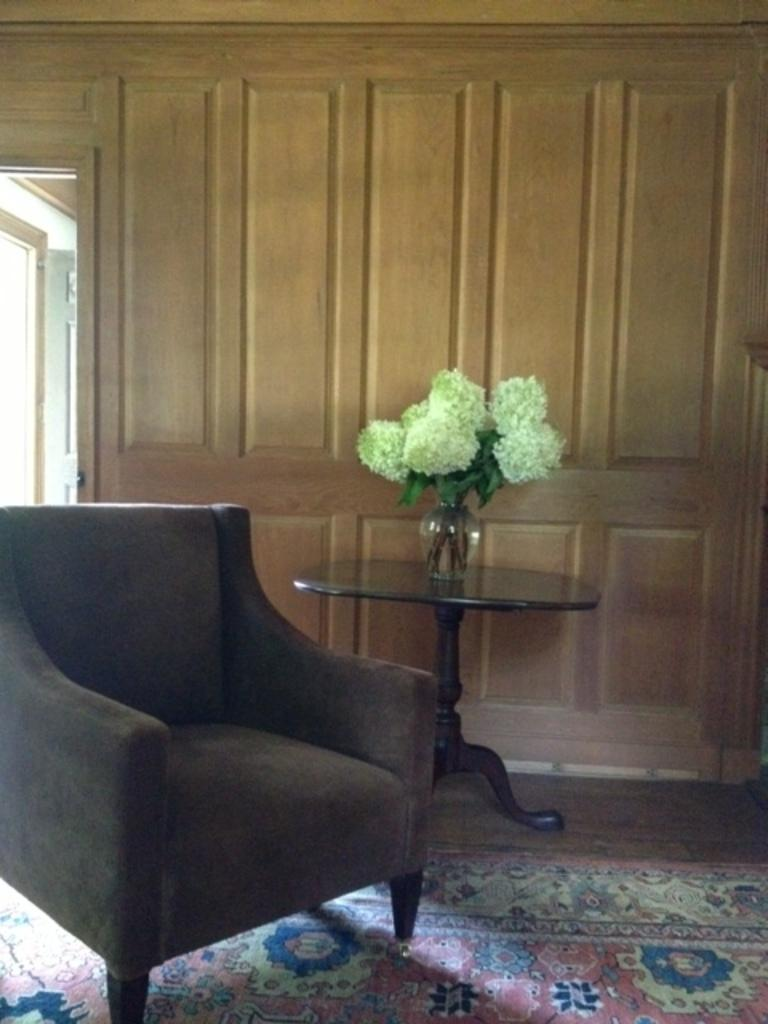What type of furniture is in the image? There is a chair in the image. What is on the table in the image? There is a flower vase on a table in the image. What type of storage units are beside the table in the image? Wooden cupboards are present beside the table in the image. What type of business is being conducted in the image? There is no indication of a business being conducted in the image; it primarily features furniture and a flower vase. What type of caption would you write for the image? The image does not have a caption, so it is not possible to write one based on the information provided. 